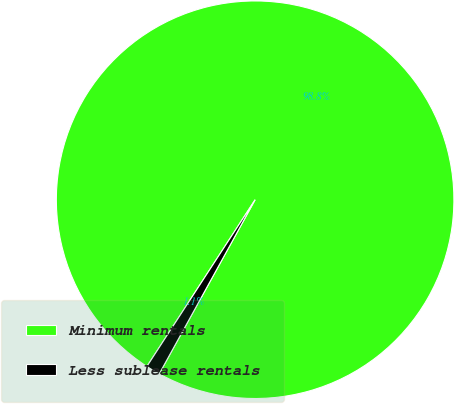<chart> <loc_0><loc_0><loc_500><loc_500><pie_chart><fcel>Minimum rentals<fcel>Less sublease rentals<nl><fcel>98.85%<fcel>1.15%<nl></chart> 